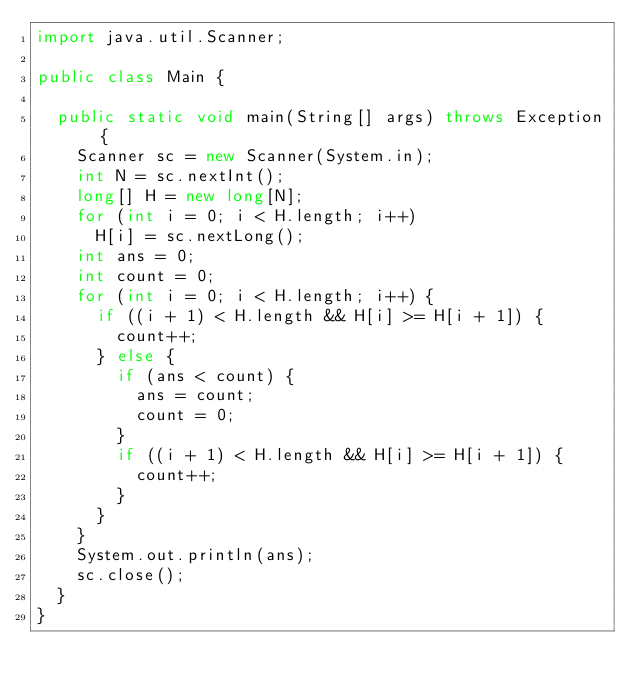Convert code to text. <code><loc_0><loc_0><loc_500><loc_500><_Java_>import java.util.Scanner;

public class Main {

	public static void main(String[] args) throws Exception {
		Scanner sc = new Scanner(System.in);
		int N = sc.nextInt();
		long[] H = new long[N];
		for (int i = 0; i < H.length; i++)
			H[i] = sc.nextLong();
		int ans = 0;
		int count = 0;
		for (int i = 0; i < H.length; i++) {
			if ((i + 1) < H.length && H[i] >= H[i + 1]) {
				count++;
			} else {
				if (ans < count) {
					ans = count;
					count = 0;
				}
				if ((i + 1) < H.length && H[i] >= H[i + 1]) {
					count++;
				}
			}
		}
		System.out.println(ans);
		sc.close();
	}
}</code> 